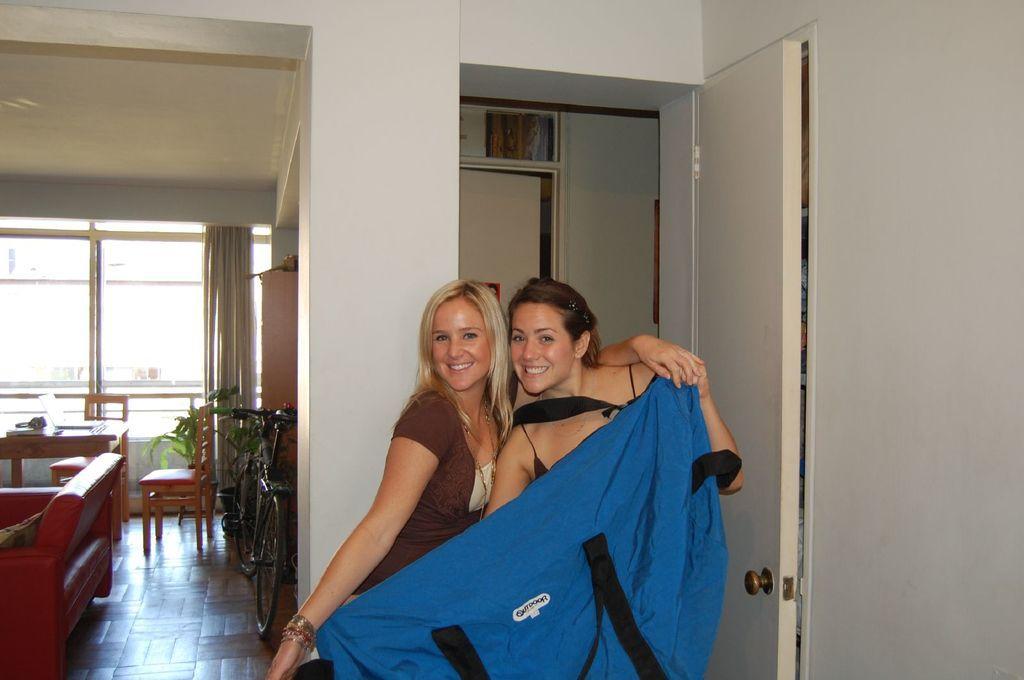Could you give a brief overview of what you see in this image? In this image we can see two women standing on the ground. One woman is wearing a brown shirt and holding a cloth in her hand. to the left side of the image we can see a sofa, chairs, table and a bicycle placed on the ground. In the background, we can see see doors, curtain and a window. 